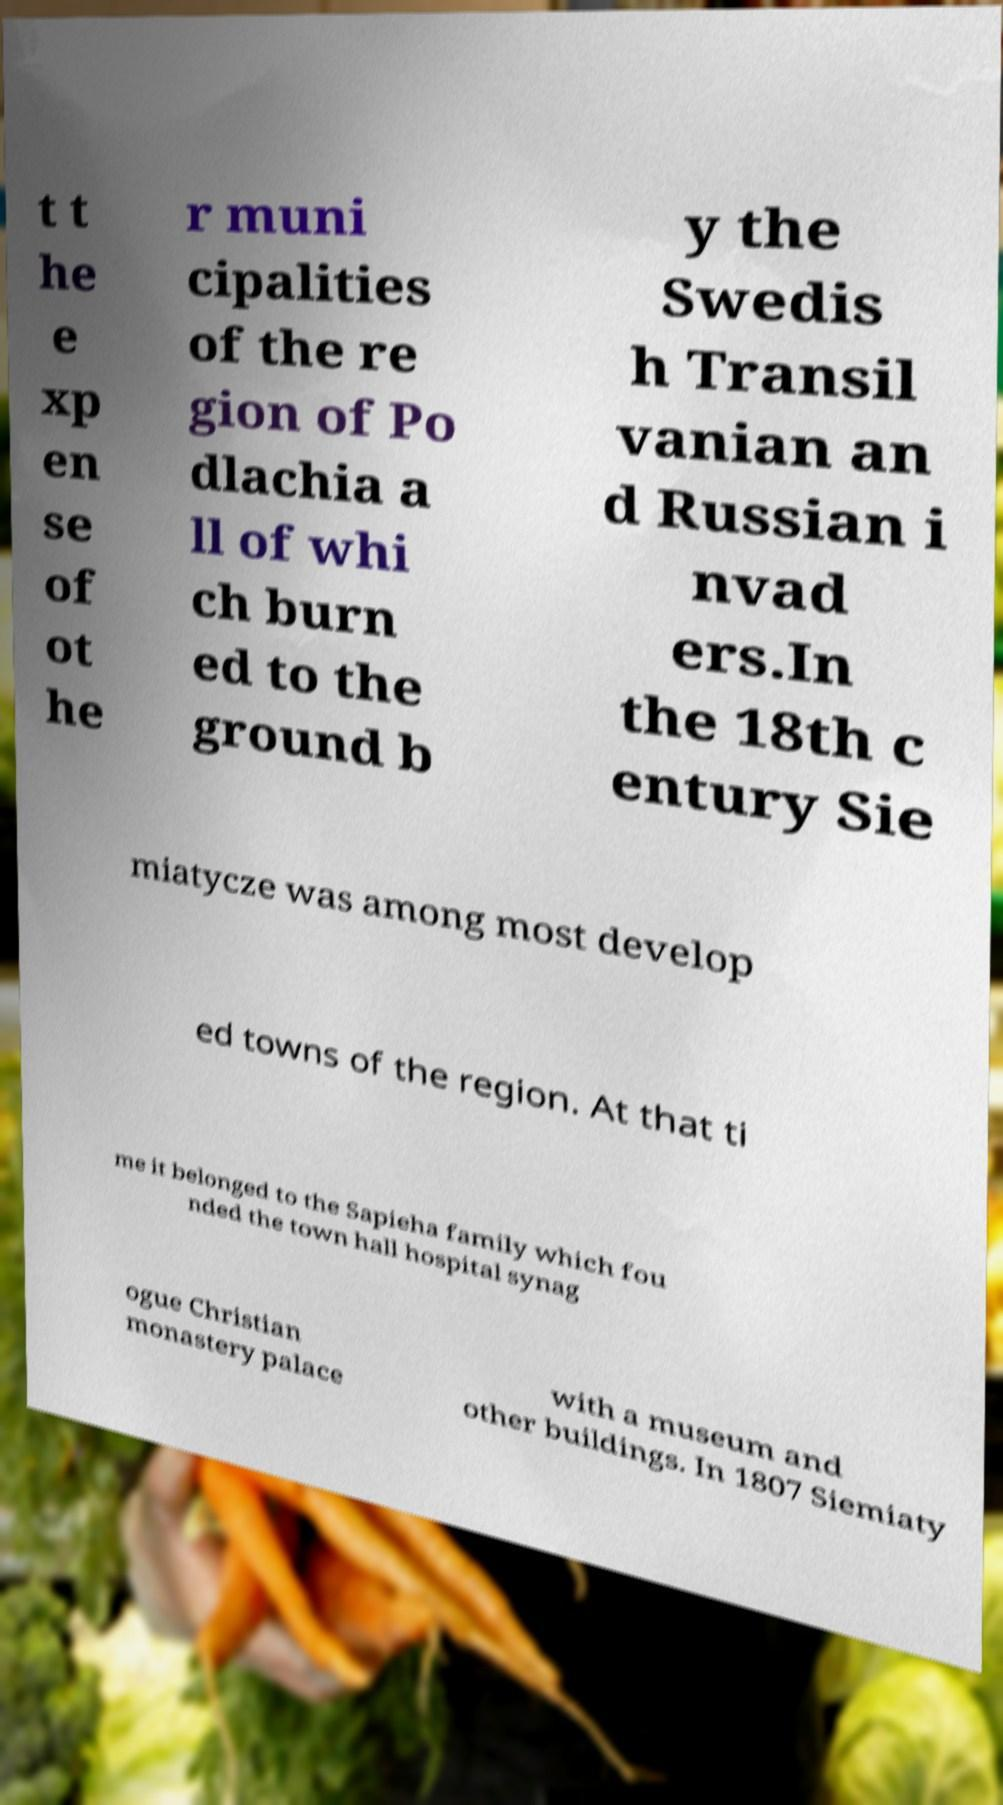Can you accurately transcribe the text from the provided image for me? t t he e xp en se of ot he r muni cipalities of the re gion of Po dlachia a ll of whi ch burn ed to the ground b y the Swedis h Transil vanian an d Russian i nvad ers.In the 18th c entury Sie miatycze was among most develop ed towns of the region. At that ti me it belonged to the Sapieha family which fou nded the town hall hospital synag ogue Christian monastery palace with a museum and other buildings. In 1807 Siemiaty 